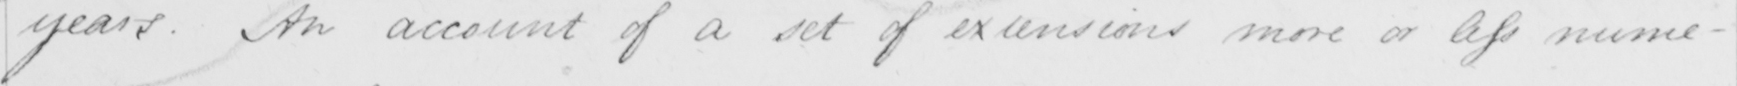Please transcribe the handwritten text in this image. years . An account of a set of extensions more or less nume- 